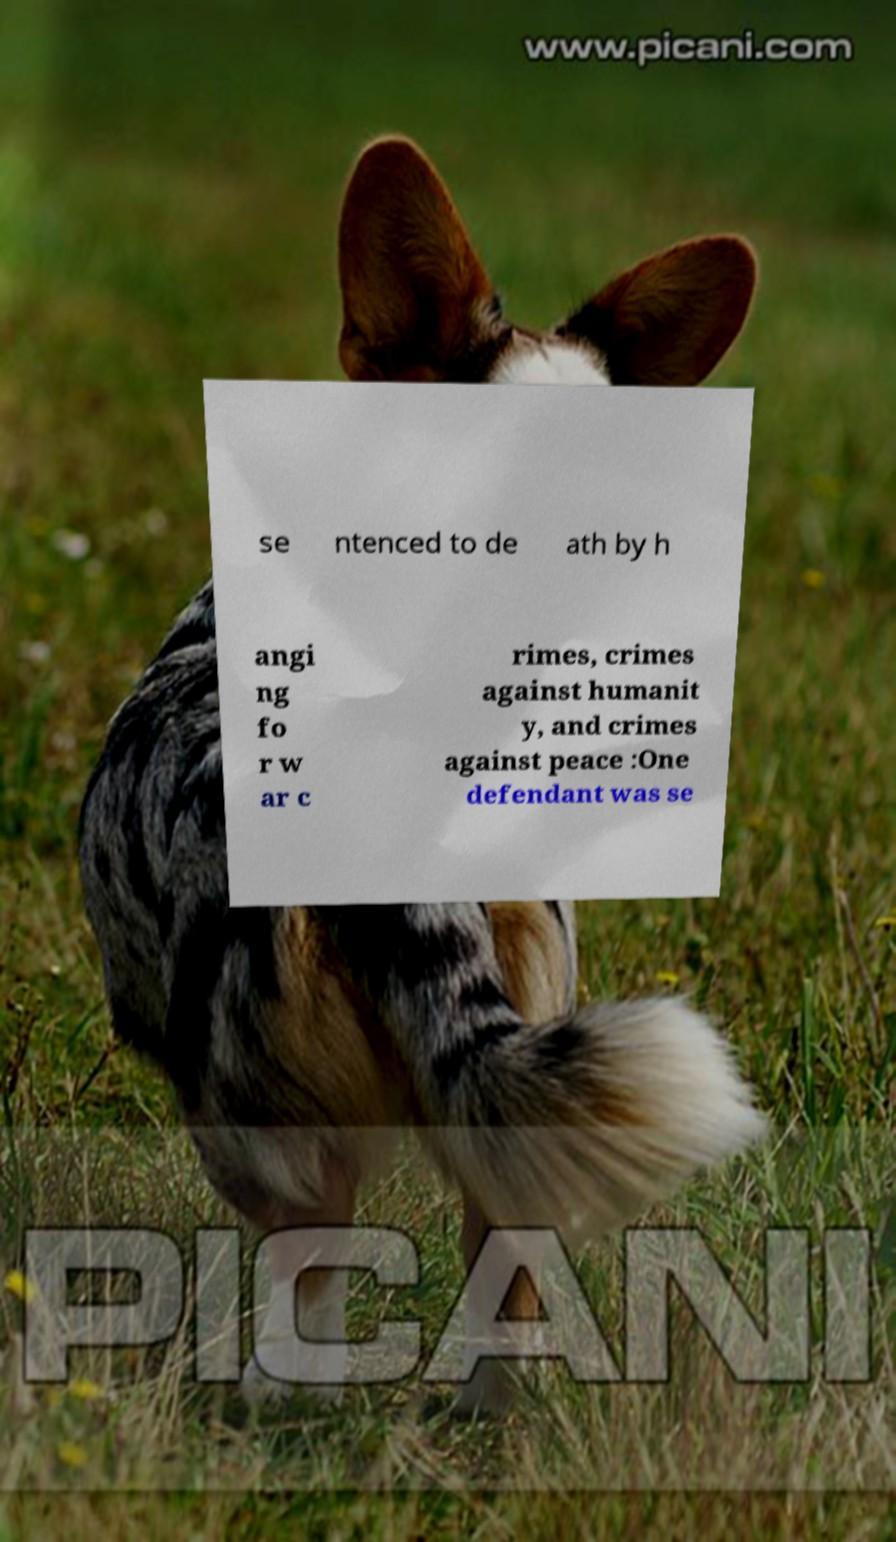Can you accurately transcribe the text from the provided image for me? se ntenced to de ath by h angi ng fo r w ar c rimes, crimes against humanit y, and crimes against peace :One defendant was se 